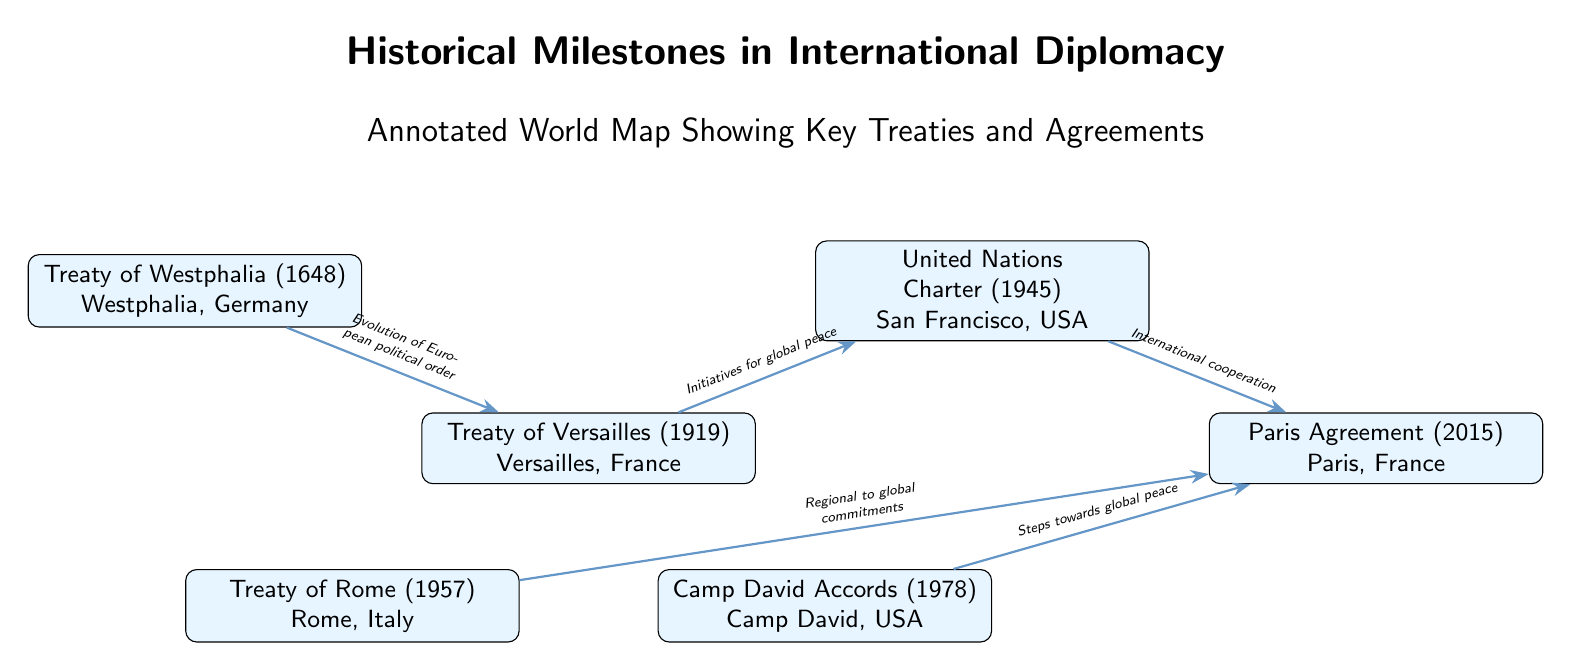What is the first treaty shown in the diagram? The diagram starts with the Treaty of Westphalia, which is depicted at the top left position. This treaty is highlighted clearly as the first milestone in the timeline of international diplomacy.
Answer: Treaty of Westphalia How many treaties are represented in the diagram? The diagram features a total of six treaties or agreements, indicated by the number of nodes present in the illustration. Each node represents a distinct treaty, and there are six nodes in total.
Answer: 6 What is the relationship between the Treaty of Versailles and the United Nations Charter? The diagram shows an edge connecting the Treaty of Versailles to the United Nations Charter, with a label that reads "Initiatives for global peace." This indicates that the Treaty of Versailles paved the way for the establishment of the UN.
Answer: Initiatives for global peace What location is associated with the Treaty of Rome? The Treaty of Rome is associated with Rome, Italy, as specified within the node that describes this treaty. The geographical location is integral to understanding the context of the treaty.
Answer: Rome, Italy Which treaty is linked to the concept of "International cooperation"? According to the diagram, the United Nations Charter is connected to the concept of "International cooperation," reflecting the goals and purposes of the UN in the realm of global diplomacy.
Answer: United Nations Charter What milestone occurs after the Camp David Accords in the diagram? Following the Camp David Accords, the next milestone depicted is the Paris Agreement, illustrating a progression in diplomatic efforts towards global peace and climate action. The edge shows this relationship.
Answer: Paris Agreement Which treaty reflects "Regional to global commitments"? The diagram indicates that the Treaty of Rome reflects "Regional to global commitments," showing its importance as a foundational agreement that contributed to broader international cooperation.
Answer: Treaty of Rome What is the overall theme presented in the diagram? The overall theme presented in the diagram is "Historical Milestones in International Diplomacy," which captures the essence of significant treaties that shaped diplomatic relations globally. This is specified in the header of the diagram.
Answer: Historical Milestones in International Diplomacy 